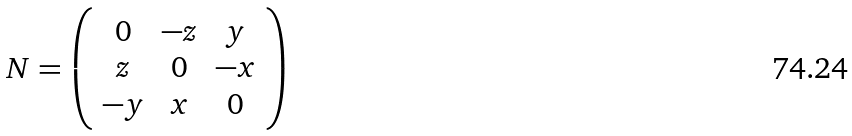<formula> <loc_0><loc_0><loc_500><loc_500>N = \left ( \begin{array} { c c c } 0 & - z & y \\ z & 0 & - x \\ - y & x & 0 \end{array} \right )</formula> 